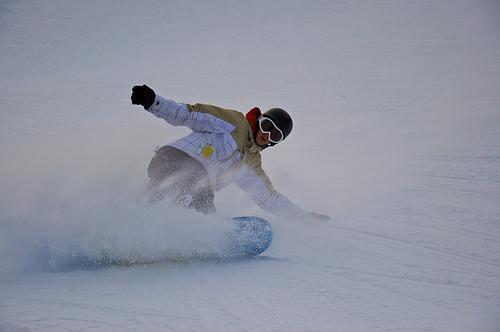How many people are snowboarding?
Give a very brief answer. 1. 